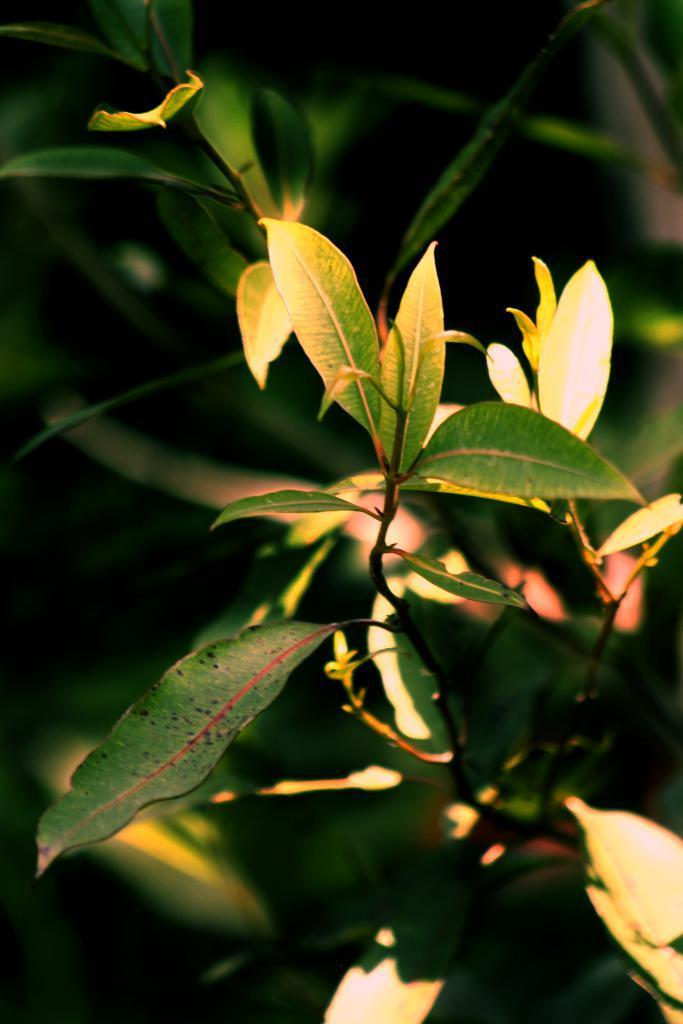Describe this image in one or two sentences. In this picture there is a green leaves plant. Behind there is a blur background. 